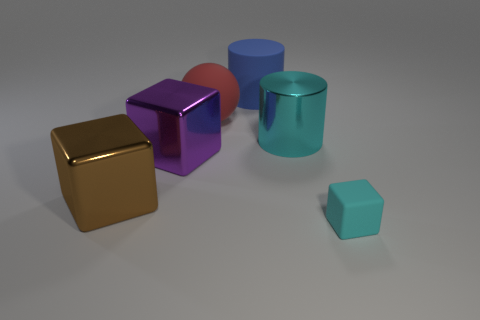Is there any other thing that has the same size as the cyan matte cube?
Provide a succinct answer. No. Is the number of red things to the left of the big red rubber thing the same as the number of large matte things that are on the left side of the large brown metallic object?
Your answer should be compact. Yes. There is a big matte object that is left of the large blue rubber cylinder; is it the same shape as the large brown shiny object?
Provide a short and direct response. No. What shape is the cyan thing that is on the left side of the matte object right of the cyan thing on the left side of the small block?
Make the answer very short. Cylinder. What shape is the large thing that is the same color as the tiny matte cube?
Your response must be concise. Cylinder. What is the big object that is both on the right side of the purple block and in front of the red matte sphere made of?
Your response must be concise. Metal. Are there fewer big cylinders than big brown things?
Provide a short and direct response. No. Do the big red matte object and the cyan thing that is behind the brown shiny object have the same shape?
Keep it short and to the point. No. Is the size of the cyan object that is behind the brown thing the same as the purple cube?
Provide a short and direct response. Yes. There is a cyan thing that is the same size as the purple metallic cube; what is its shape?
Your response must be concise. Cylinder. 